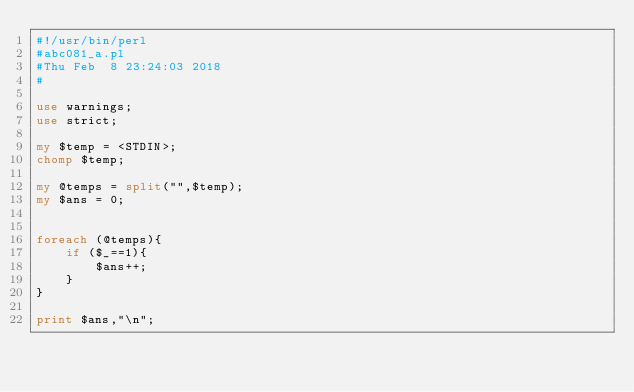<code> <loc_0><loc_0><loc_500><loc_500><_Perl_>#!/usr/bin/perl
#abc081_a.pl
#Thu Feb  8 23:24:03 2018
#

use warnings;
use strict;

my $temp = <STDIN>;
chomp $temp;

my @temps = split("",$temp);
my $ans = 0;


foreach (@temps){
	if ($_==1){
		$ans++;
	}
}

print $ans,"\n";</code> 